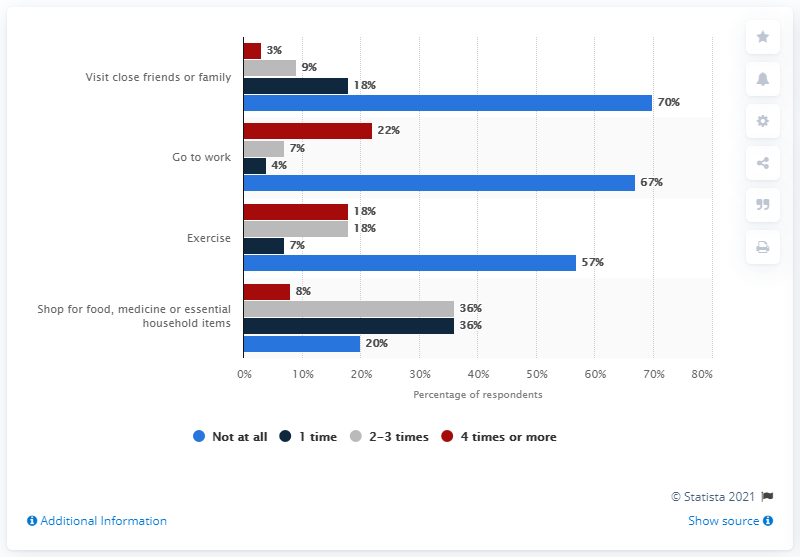Outline some significant characteristics in this image. The sum of all the red bars is 51. The value of the highest blue bar is 70. 